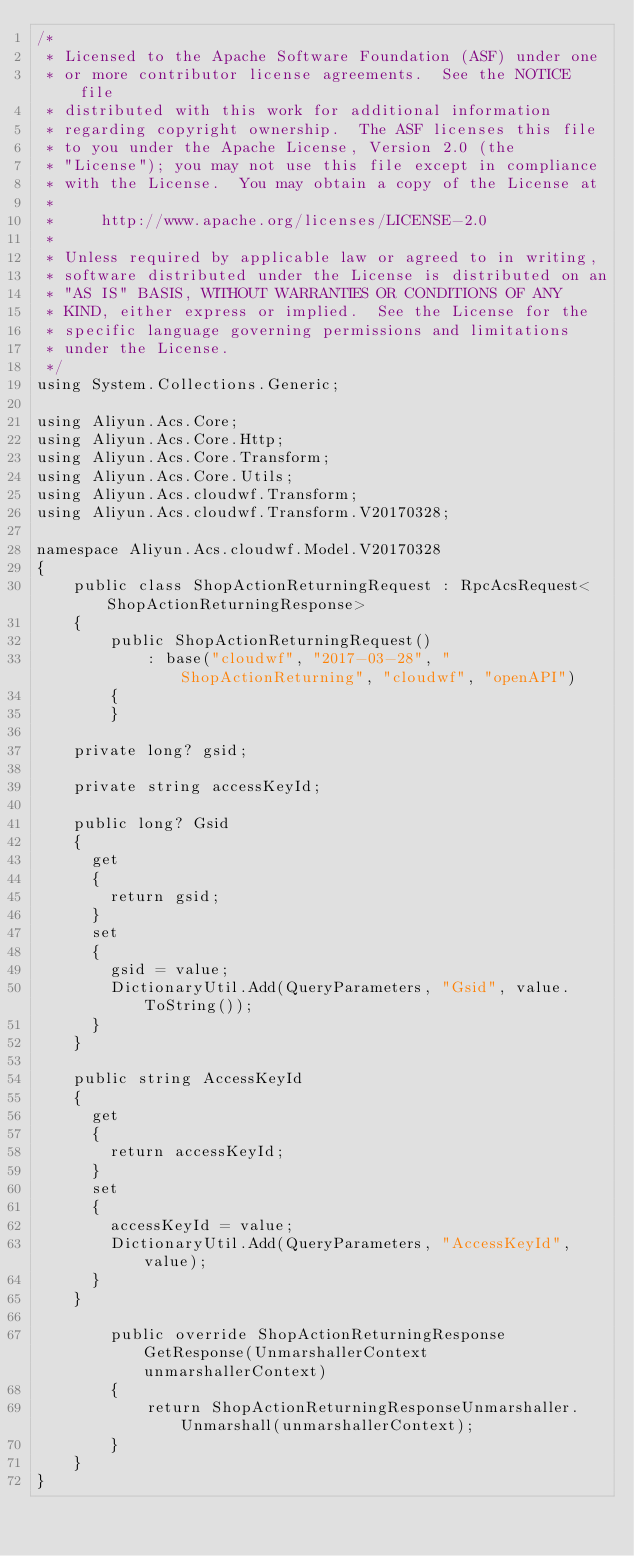Convert code to text. <code><loc_0><loc_0><loc_500><loc_500><_C#_>/*
 * Licensed to the Apache Software Foundation (ASF) under one
 * or more contributor license agreements.  See the NOTICE file
 * distributed with this work for additional information
 * regarding copyright ownership.  The ASF licenses this file
 * to you under the Apache License, Version 2.0 (the
 * "License"); you may not use this file except in compliance
 * with the License.  You may obtain a copy of the License at
 *
 *     http://www.apache.org/licenses/LICENSE-2.0
 *
 * Unless required by applicable law or agreed to in writing,
 * software distributed under the License is distributed on an
 * "AS IS" BASIS, WITHOUT WARRANTIES OR CONDITIONS OF ANY
 * KIND, either express or implied.  See the License for the
 * specific language governing permissions and limitations
 * under the License.
 */
using System.Collections.Generic;

using Aliyun.Acs.Core;
using Aliyun.Acs.Core.Http;
using Aliyun.Acs.Core.Transform;
using Aliyun.Acs.Core.Utils;
using Aliyun.Acs.cloudwf.Transform;
using Aliyun.Acs.cloudwf.Transform.V20170328;

namespace Aliyun.Acs.cloudwf.Model.V20170328
{
    public class ShopActionReturningRequest : RpcAcsRequest<ShopActionReturningResponse>
    {
        public ShopActionReturningRequest()
            : base("cloudwf", "2017-03-28", "ShopActionReturning", "cloudwf", "openAPI")
        {
        }

		private long? gsid;

		private string accessKeyId;

		public long? Gsid
		{
			get
			{
				return gsid;
			}
			set	
			{
				gsid = value;
				DictionaryUtil.Add(QueryParameters, "Gsid", value.ToString());
			}
		}

		public string AccessKeyId
		{
			get
			{
				return accessKeyId;
			}
			set	
			{
				accessKeyId = value;
				DictionaryUtil.Add(QueryParameters, "AccessKeyId", value);
			}
		}

        public override ShopActionReturningResponse GetResponse(UnmarshallerContext unmarshallerContext)
        {
            return ShopActionReturningResponseUnmarshaller.Unmarshall(unmarshallerContext);
        }
    }
}
</code> 